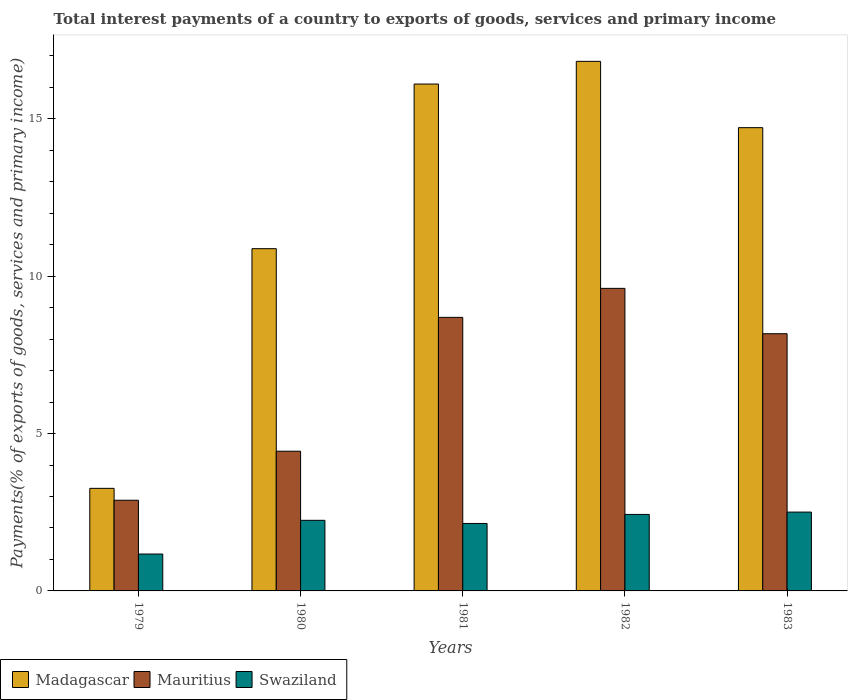How many different coloured bars are there?
Offer a terse response. 3. How many groups of bars are there?
Offer a very short reply. 5. Are the number of bars per tick equal to the number of legend labels?
Keep it short and to the point. Yes. How many bars are there on the 3rd tick from the left?
Provide a short and direct response. 3. How many bars are there on the 1st tick from the right?
Provide a succinct answer. 3. What is the total interest payments in Madagascar in 1979?
Your response must be concise. 3.26. Across all years, what is the maximum total interest payments in Mauritius?
Offer a very short reply. 9.61. Across all years, what is the minimum total interest payments in Swaziland?
Your answer should be very brief. 1.17. In which year was the total interest payments in Madagascar minimum?
Your answer should be compact. 1979. What is the total total interest payments in Mauritius in the graph?
Offer a very short reply. 33.8. What is the difference between the total interest payments in Swaziland in 1979 and that in 1981?
Your response must be concise. -0.97. What is the difference between the total interest payments in Mauritius in 1979 and the total interest payments in Madagascar in 1980?
Provide a short and direct response. -7.99. What is the average total interest payments in Mauritius per year?
Give a very brief answer. 6.76. In the year 1982, what is the difference between the total interest payments in Mauritius and total interest payments in Madagascar?
Ensure brevity in your answer.  -7.21. What is the ratio of the total interest payments in Mauritius in 1982 to that in 1983?
Keep it short and to the point. 1.18. Is the difference between the total interest payments in Mauritius in 1980 and 1981 greater than the difference between the total interest payments in Madagascar in 1980 and 1981?
Provide a succinct answer. Yes. What is the difference between the highest and the second highest total interest payments in Swaziland?
Offer a very short reply. 0.07. What is the difference between the highest and the lowest total interest payments in Mauritius?
Make the answer very short. 6.73. In how many years, is the total interest payments in Madagascar greater than the average total interest payments in Madagascar taken over all years?
Give a very brief answer. 3. Is the sum of the total interest payments in Madagascar in 1980 and 1982 greater than the maximum total interest payments in Swaziland across all years?
Your answer should be compact. Yes. What does the 1st bar from the left in 1982 represents?
Keep it short and to the point. Madagascar. What does the 2nd bar from the right in 1979 represents?
Your answer should be compact. Mauritius. Is it the case that in every year, the sum of the total interest payments in Swaziland and total interest payments in Madagascar is greater than the total interest payments in Mauritius?
Provide a short and direct response. Yes. How many bars are there?
Offer a very short reply. 15. Are the values on the major ticks of Y-axis written in scientific E-notation?
Ensure brevity in your answer.  No. Does the graph contain any zero values?
Provide a short and direct response. No. Does the graph contain grids?
Make the answer very short. No. How many legend labels are there?
Keep it short and to the point. 3. How are the legend labels stacked?
Give a very brief answer. Horizontal. What is the title of the graph?
Provide a succinct answer. Total interest payments of a country to exports of goods, services and primary income. Does "American Samoa" appear as one of the legend labels in the graph?
Your answer should be very brief. No. What is the label or title of the Y-axis?
Your answer should be very brief. Payments(% of exports of goods, services and primary income). What is the Payments(% of exports of goods, services and primary income) in Madagascar in 1979?
Your response must be concise. 3.26. What is the Payments(% of exports of goods, services and primary income) in Mauritius in 1979?
Provide a succinct answer. 2.88. What is the Payments(% of exports of goods, services and primary income) of Swaziland in 1979?
Your response must be concise. 1.17. What is the Payments(% of exports of goods, services and primary income) of Madagascar in 1980?
Provide a short and direct response. 10.87. What is the Payments(% of exports of goods, services and primary income) in Mauritius in 1980?
Give a very brief answer. 4.44. What is the Payments(% of exports of goods, services and primary income) of Swaziland in 1980?
Offer a terse response. 2.24. What is the Payments(% of exports of goods, services and primary income) of Madagascar in 1981?
Provide a succinct answer. 16.11. What is the Payments(% of exports of goods, services and primary income) of Mauritius in 1981?
Keep it short and to the point. 8.69. What is the Payments(% of exports of goods, services and primary income) of Swaziland in 1981?
Your answer should be compact. 2.14. What is the Payments(% of exports of goods, services and primary income) in Madagascar in 1982?
Your answer should be very brief. 16.83. What is the Payments(% of exports of goods, services and primary income) of Mauritius in 1982?
Provide a succinct answer. 9.61. What is the Payments(% of exports of goods, services and primary income) of Swaziland in 1982?
Your response must be concise. 2.43. What is the Payments(% of exports of goods, services and primary income) in Madagascar in 1983?
Your answer should be very brief. 14.72. What is the Payments(% of exports of goods, services and primary income) of Mauritius in 1983?
Your answer should be compact. 8.17. What is the Payments(% of exports of goods, services and primary income) in Swaziland in 1983?
Offer a terse response. 2.5. Across all years, what is the maximum Payments(% of exports of goods, services and primary income) in Madagascar?
Give a very brief answer. 16.83. Across all years, what is the maximum Payments(% of exports of goods, services and primary income) in Mauritius?
Give a very brief answer. 9.61. Across all years, what is the maximum Payments(% of exports of goods, services and primary income) in Swaziland?
Your answer should be compact. 2.5. Across all years, what is the minimum Payments(% of exports of goods, services and primary income) in Madagascar?
Provide a short and direct response. 3.26. Across all years, what is the minimum Payments(% of exports of goods, services and primary income) of Mauritius?
Your response must be concise. 2.88. Across all years, what is the minimum Payments(% of exports of goods, services and primary income) in Swaziland?
Ensure brevity in your answer.  1.17. What is the total Payments(% of exports of goods, services and primary income) of Madagascar in the graph?
Make the answer very short. 61.79. What is the total Payments(% of exports of goods, services and primary income) in Mauritius in the graph?
Your response must be concise. 33.8. What is the total Payments(% of exports of goods, services and primary income) of Swaziland in the graph?
Ensure brevity in your answer.  10.49. What is the difference between the Payments(% of exports of goods, services and primary income) in Madagascar in 1979 and that in 1980?
Your response must be concise. -7.62. What is the difference between the Payments(% of exports of goods, services and primary income) of Mauritius in 1979 and that in 1980?
Offer a very short reply. -1.56. What is the difference between the Payments(% of exports of goods, services and primary income) in Swaziland in 1979 and that in 1980?
Offer a very short reply. -1.07. What is the difference between the Payments(% of exports of goods, services and primary income) in Madagascar in 1979 and that in 1981?
Offer a very short reply. -12.85. What is the difference between the Payments(% of exports of goods, services and primary income) in Mauritius in 1979 and that in 1981?
Your answer should be compact. -5.81. What is the difference between the Payments(% of exports of goods, services and primary income) in Swaziland in 1979 and that in 1981?
Provide a short and direct response. -0.97. What is the difference between the Payments(% of exports of goods, services and primary income) of Madagascar in 1979 and that in 1982?
Provide a short and direct response. -13.57. What is the difference between the Payments(% of exports of goods, services and primary income) of Mauritius in 1979 and that in 1982?
Offer a very short reply. -6.73. What is the difference between the Payments(% of exports of goods, services and primary income) of Swaziland in 1979 and that in 1982?
Your response must be concise. -1.26. What is the difference between the Payments(% of exports of goods, services and primary income) of Madagascar in 1979 and that in 1983?
Make the answer very short. -11.46. What is the difference between the Payments(% of exports of goods, services and primary income) of Mauritius in 1979 and that in 1983?
Give a very brief answer. -5.29. What is the difference between the Payments(% of exports of goods, services and primary income) of Swaziland in 1979 and that in 1983?
Offer a terse response. -1.33. What is the difference between the Payments(% of exports of goods, services and primary income) of Madagascar in 1980 and that in 1981?
Your answer should be very brief. -5.23. What is the difference between the Payments(% of exports of goods, services and primary income) in Mauritius in 1980 and that in 1981?
Keep it short and to the point. -4.25. What is the difference between the Payments(% of exports of goods, services and primary income) in Swaziland in 1980 and that in 1981?
Offer a terse response. 0.1. What is the difference between the Payments(% of exports of goods, services and primary income) in Madagascar in 1980 and that in 1982?
Give a very brief answer. -5.95. What is the difference between the Payments(% of exports of goods, services and primary income) of Mauritius in 1980 and that in 1982?
Offer a terse response. -5.17. What is the difference between the Payments(% of exports of goods, services and primary income) of Swaziland in 1980 and that in 1982?
Your answer should be very brief. -0.19. What is the difference between the Payments(% of exports of goods, services and primary income) in Madagascar in 1980 and that in 1983?
Provide a succinct answer. -3.85. What is the difference between the Payments(% of exports of goods, services and primary income) of Mauritius in 1980 and that in 1983?
Keep it short and to the point. -3.73. What is the difference between the Payments(% of exports of goods, services and primary income) in Swaziland in 1980 and that in 1983?
Make the answer very short. -0.26. What is the difference between the Payments(% of exports of goods, services and primary income) of Madagascar in 1981 and that in 1982?
Provide a short and direct response. -0.72. What is the difference between the Payments(% of exports of goods, services and primary income) in Mauritius in 1981 and that in 1982?
Your response must be concise. -0.92. What is the difference between the Payments(% of exports of goods, services and primary income) of Swaziland in 1981 and that in 1982?
Ensure brevity in your answer.  -0.29. What is the difference between the Payments(% of exports of goods, services and primary income) in Madagascar in 1981 and that in 1983?
Keep it short and to the point. 1.39. What is the difference between the Payments(% of exports of goods, services and primary income) of Mauritius in 1981 and that in 1983?
Your answer should be very brief. 0.52. What is the difference between the Payments(% of exports of goods, services and primary income) of Swaziland in 1981 and that in 1983?
Keep it short and to the point. -0.36. What is the difference between the Payments(% of exports of goods, services and primary income) of Madagascar in 1982 and that in 1983?
Ensure brevity in your answer.  2.11. What is the difference between the Payments(% of exports of goods, services and primary income) of Mauritius in 1982 and that in 1983?
Ensure brevity in your answer.  1.44. What is the difference between the Payments(% of exports of goods, services and primary income) in Swaziland in 1982 and that in 1983?
Give a very brief answer. -0.07. What is the difference between the Payments(% of exports of goods, services and primary income) in Madagascar in 1979 and the Payments(% of exports of goods, services and primary income) in Mauritius in 1980?
Your answer should be compact. -1.18. What is the difference between the Payments(% of exports of goods, services and primary income) in Madagascar in 1979 and the Payments(% of exports of goods, services and primary income) in Swaziland in 1980?
Give a very brief answer. 1.02. What is the difference between the Payments(% of exports of goods, services and primary income) in Mauritius in 1979 and the Payments(% of exports of goods, services and primary income) in Swaziland in 1980?
Your answer should be compact. 0.64. What is the difference between the Payments(% of exports of goods, services and primary income) in Madagascar in 1979 and the Payments(% of exports of goods, services and primary income) in Mauritius in 1981?
Give a very brief answer. -5.43. What is the difference between the Payments(% of exports of goods, services and primary income) in Madagascar in 1979 and the Payments(% of exports of goods, services and primary income) in Swaziland in 1981?
Give a very brief answer. 1.12. What is the difference between the Payments(% of exports of goods, services and primary income) of Mauritius in 1979 and the Payments(% of exports of goods, services and primary income) of Swaziland in 1981?
Provide a succinct answer. 0.74. What is the difference between the Payments(% of exports of goods, services and primary income) of Madagascar in 1979 and the Payments(% of exports of goods, services and primary income) of Mauritius in 1982?
Ensure brevity in your answer.  -6.35. What is the difference between the Payments(% of exports of goods, services and primary income) of Madagascar in 1979 and the Payments(% of exports of goods, services and primary income) of Swaziland in 1982?
Your answer should be very brief. 0.83. What is the difference between the Payments(% of exports of goods, services and primary income) of Mauritius in 1979 and the Payments(% of exports of goods, services and primary income) of Swaziland in 1982?
Provide a succinct answer. 0.45. What is the difference between the Payments(% of exports of goods, services and primary income) in Madagascar in 1979 and the Payments(% of exports of goods, services and primary income) in Mauritius in 1983?
Your answer should be very brief. -4.91. What is the difference between the Payments(% of exports of goods, services and primary income) of Madagascar in 1979 and the Payments(% of exports of goods, services and primary income) of Swaziland in 1983?
Make the answer very short. 0.75. What is the difference between the Payments(% of exports of goods, services and primary income) in Mauritius in 1979 and the Payments(% of exports of goods, services and primary income) in Swaziland in 1983?
Ensure brevity in your answer.  0.38. What is the difference between the Payments(% of exports of goods, services and primary income) of Madagascar in 1980 and the Payments(% of exports of goods, services and primary income) of Mauritius in 1981?
Your answer should be compact. 2.18. What is the difference between the Payments(% of exports of goods, services and primary income) in Madagascar in 1980 and the Payments(% of exports of goods, services and primary income) in Swaziland in 1981?
Offer a terse response. 8.73. What is the difference between the Payments(% of exports of goods, services and primary income) in Mauritius in 1980 and the Payments(% of exports of goods, services and primary income) in Swaziland in 1981?
Give a very brief answer. 2.3. What is the difference between the Payments(% of exports of goods, services and primary income) in Madagascar in 1980 and the Payments(% of exports of goods, services and primary income) in Mauritius in 1982?
Provide a succinct answer. 1.26. What is the difference between the Payments(% of exports of goods, services and primary income) in Madagascar in 1980 and the Payments(% of exports of goods, services and primary income) in Swaziland in 1982?
Your response must be concise. 8.44. What is the difference between the Payments(% of exports of goods, services and primary income) in Mauritius in 1980 and the Payments(% of exports of goods, services and primary income) in Swaziland in 1982?
Keep it short and to the point. 2.01. What is the difference between the Payments(% of exports of goods, services and primary income) in Madagascar in 1980 and the Payments(% of exports of goods, services and primary income) in Mauritius in 1983?
Provide a succinct answer. 2.7. What is the difference between the Payments(% of exports of goods, services and primary income) in Madagascar in 1980 and the Payments(% of exports of goods, services and primary income) in Swaziland in 1983?
Offer a very short reply. 8.37. What is the difference between the Payments(% of exports of goods, services and primary income) of Mauritius in 1980 and the Payments(% of exports of goods, services and primary income) of Swaziland in 1983?
Provide a short and direct response. 1.93. What is the difference between the Payments(% of exports of goods, services and primary income) in Madagascar in 1981 and the Payments(% of exports of goods, services and primary income) in Mauritius in 1982?
Your answer should be compact. 6.49. What is the difference between the Payments(% of exports of goods, services and primary income) of Madagascar in 1981 and the Payments(% of exports of goods, services and primary income) of Swaziland in 1982?
Ensure brevity in your answer.  13.67. What is the difference between the Payments(% of exports of goods, services and primary income) in Mauritius in 1981 and the Payments(% of exports of goods, services and primary income) in Swaziland in 1982?
Make the answer very short. 6.26. What is the difference between the Payments(% of exports of goods, services and primary income) in Madagascar in 1981 and the Payments(% of exports of goods, services and primary income) in Mauritius in 1983?
Keep it short and to the point. 7.93. What is the difference between the Payments(% of exports of goods, services and primary income) of Madagascar in 1981 and the Payments(% of exports of goods, services and primary income) of Swaziland in 1983?
Provide a succinct answer. 13.6. What is the difference between the Payments(% of exports of goods, services and primary income) of Mauritius in 1981 and the Payments(% of exports of goods, services and primary income) of Swaziland in 1983?
Offer a very short reply. 6.19. What is the difference between the Payments(% of exports of goods, services and primary income) of Madagascar in 1982 and the Payments(% of exports of goods, services and primary income) of Mauritius in 1983?
Your response must be concise. 8.65. What is the difference between the Payments(% of exports of goods, services and primary income) in Madagascar in 1982 and the Payments(% of exports of goods, services and primary income) in Swaziland in 1983?
Offer a very short reply. 14.32. What is the difference between the Payments(% of exports of goods, services and primary income) in Mauritius in 1982 and the Payments(% of exports of goods, services and primary income) in Swaziland in 1983?
Your answer should be compact. 7.11. What is the average Payments(% of exports of goods, services and primary income) of Madagascar per year?
Your answer should be very brief. 12.36. What is the average Payments(% of exports of goods, services and primary income) of Mauritius per year?
Give a very brief answer. 6.76. What is the average Payments(% of exports of goods, services and primary income) of Swaziland per year?
Provide a short and direct response. 2.1. In the year 1979, what is the difference between the Payments(% of exports of goods, services and primary income) in Madagascar and Payments(% of exports of goods, services and primary income) in Mauritius?
Provide a short and direct response. 0.38. In the year 1979, what is the difference between the Payments(% of exports of goods, services and primary income) of Madagascar and Payments(% of exports of goods, services and primary income) of Swaziland?
Provide a succinct answer. 2.09. In the year 1979, what is the difference between the Payments(% of exports of goods, services and primary income) in Mauritius and Payments(% of exports of goods, services and primary income) in Swaziland?
Make the answer very short. 1.71. In the year 1980, what is the difference between the Payments(% of exports of goods, services and primary income) of Madagascar and Payments(% of exports of goods, services and primary income) of Mauritius?
Provide a short and direct response. 6.44. In the year 1980, what is the difference between the Payments(% of exports of goods, services and primary income) of Madagascar and Payments(% of exports of goods, services and primary income) of Swaziland?
Provide a short and direct response. 8.63. In the year 1980, what is the difference between the Payments(% of exports of goods, services and primary income) in Mauritius and Payments(% of exports of goods, services and primary income) in Swaziland?
Give a very brief answer. 2.2. In the year 1981, what is the difference between the Payments(% of exports of goods, services and primary income) in Madagascar and Payments(% of exports of goods, services and primary income) in Mauritius?
Keep it short and to the point. 7.41. In the year 1981, what is the difference between the Payments(% of exports of goods, services and primary income) in Madagascar and Payments(% of exports of goods, services and primary income) in Swaziland?
Provide a succinct answer. 13.96. In the year 1981, what is the difference between the Payments(% of exports of goods, services and primary income) of Mauritius and Payments(% of exports of goods, services and primary income) of Swaziland?
Provide a short and direct response. 6.55. In the year 1982, what is the difference between the Payments(% of exports of goods, services and primary income) in Madagascar and Payments(% of exports of goods, services and primary income) in Mauritius?
Provide a succinct answer. 7.21. In the year 1982, what is the difference between the Payments(% of exports of goods, services and primary income) of Madagascar and Payments(% of exports of goods, services and primary income) of Swaziland?
Offer a terse response. 14.4. In the year 1982, what is the difference between the Payments(% of exports of goods, services and primary income) in Mauritius and Payments(% of exports of goods, services and primary income) in Swaziland?
Your answer should be compact. 7.18. In the year 1983, what is the difference between the Payments(% of exports of goods, services and primary income) in Madagascar and Payments(% of exports of goods, services and primary income) in Mauritius?
Keep it short and to the point. 6.55. In the year 1983, what is the difference between the Payments(% of exports of goods, services and primary income) of Madagascar and Payments(% of exports of goods, services and primary income) of Swaziland?
Provide a short and direct response. 12.21. In the year 1983, what is the difference between the Payments(% of exports of goods, services and primary income) in Mauritius and Payments(% of exports of goods, services and primary income) in Swaziland?
Give a very brief answer. 5.67. What is the ratio of the Payments(% of exports of goods, services and primary income) of Madagascar in 1979 to that in 1980?
Your response must be concise. 0.3. What is the ratio of the Payments(% of exports of goods, services and primary income) in Mauritius in 1979 to that in 1980?
Your answer should be compact. 0.65. What is the ratio of the Payments(% of exports of goods, services and primary income) of Swaziland in 1979 to that in 1980?
Offer a terse response. 0.52. What is the ratio of the Payments(% of exports of goods, services and primary income) in Madagascar in 1979 to that in 1981?
Provide a succinct answer. 0.2. What is the ratio of the Payments(% of exports of goods, services and primary income) of Mauritius in 1979 to that in 1981?
Your answer should be compact. 0.33. What is the ratio of the Payments(% of exports of goods, services and primary income) in Swaziland in 1979 to that in 1981?
Offer a terse response. 0.55. What is the ratio of the Payments(% of exports of goods, services and primary income) in Madagascar in 1979 to that in 1982?
Your answer should be very brief. 0.19. What is the ratio of the Payments(% of exports of goods, services and primary income) in Mauritius in 1979 to that in 1982?
Keep it short and to the point. 0.3. What is the ratio of the Payments(% of exports of goods, services and primary income) in Swaziland in 1979 to that in 1982?
Provide a succinct answer. 0.48. What is the ratio of the Payments(% of exports of goods, services and primary income) of Madagascar in 1979 to that in 1983?
Offer a terse response. 0.22. What is the ratio of the Payments(% of exports of goods, services and primary income) in Mauritius in 1979 to that in 1983?
Your answer should be very brief. 0.35. What is the ratio of the Payments(% of exports of goods, services and primary income) of Swaziland in 1979 to that in 1983?
Your response must be concise. 0.47. What is the ratio of the Payments(% of exports of goods, services and primary income) in Madagascar in 1980 to that in 1981?
Give a very brief answer. 0.68. What is the ratio of the Payments(% of exports of goods, services and primary income) in Mauritius in 1980 to that in 1981?
Keep it short and to the point. 0.51. What is the ratio of the Payments(% of exports of goods, services and primary income) of Swaziland in 1980 to that in 1981?
Make the answer very short. 1.05. What is the ratio of the Payments(% of exports of goods, services and primary income) in Madagascar in 1980 to that in 1982?
Make the answer very short. 0.65. What is the ratio of the Payments(% of exports of goods, services and primary income) of Mauritius in 1980 to that in 1982?
Provide a short and direct response. 0.46. What is the ratio of the Payments(% of exports of goods, services and primary income) of Swaziland in 1980 to that in 1982?
Provide a short and direct response. 0.92. What is the ratio of the Payments(% of exports of goods, services and primary income) of Madagascar in 1980 to that in 1983?
Ensure brevity in your answer.  0.74. What is the ratio of the Payments(% of exports of goods, services and primary income) in Mauritius in 1980 to that in 1983?
Your answer should be compact. 0.54. What is the ratio of the Payments(% of exports of goods, services and primary income) in Swaziland in 1980 to that in 1983?
Provide a succinct answer. 0.9. What is the ratio of the Payments(% of exports of goods, services and primary income) in Madagascar in 1981 to that in 1982?
Offer a very short reply. 0.96. What is the ratio of the Payments(% of exports of goods, services and primary income) of Mauritius in 1981 to that in 1982?
Offer a very short reply. 0.9. What is the ratio of the Payments(% of exports of goods, services and primary income) of Swaziland in 1981 to that in 1982?
Your response must be concise. 0.88. What is the ratio of the Payments(% of exports of goods, services and primary income) in Madagascar in 1981 to that in 1983?
Provide a short and direct response. 1.09. What is the ratio of the Payments(% of exports of goods, services and primary income) of Mauritius in 1981 to that in 1983?
Make the answer very short. 1.06. What is the ratio of the Payments(% of exports of goods, services and primary income) in Swaziland in 1981 to that in 1983?
Ensure brevity in your answer.  0.86. What is the ratio of the Payments(% of exports of goods, services and primary income) of Madagascar in 1982 to that in 1983?
Your response must be concise. 1.14. What is the ratio of the Payments(% of exports of goods, services and primary income) in Mauritius in 1982 to that in 1983?
Your response must be concise. 1.18. What is the ratio of the Payments(% of exports of goods, services and primary income) in Swaziland in 1982 to that in 1983?
Give a very brief answer. 0.97. What is the difference between the highest and the second highest Payments(% of exports of goods, services and primary income) of Madagascar?
Your answer should be very brief. 0.72. What is the difference between the highest and the second highest Payments(% of exports of goods, services and primary income) in Mauritius?
Provide a succinct answer. 0.92. What is the difference between the highest and the second highest Payments(% of exports of goods, services and primary income) in Swaziland?
Offer a terse response. 0.07. What is the difference between the highest and the lowest Payments(% of exports of goods, services and primary income) in Madagascar?
Your answer should be compact. 13.57. What is the difference between the highest and the lowest Payments(% of exports of goods, services and primary income) in Mauritius?
Your response must be concise. 6.73. What is the difference between the highest and the lowest Payments(% of exports of goods, services and primary income) in Swaziland?
Keep it short and to the point. 1.33. 